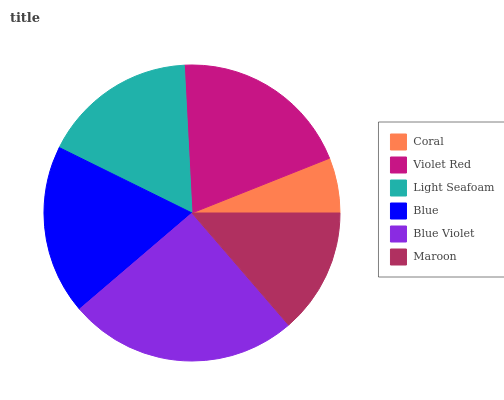Is Coral the minimum?
Answer yes or no. Yes. Is Blue Violet the maximum?
Answer yes or no. Yes. Is Violet Red the minimum?
Answer yes or no. No. Is Violet Red the maximum?
Answer yes or no. No. Is Violet Red greater than Coral?
Answer yes or no. Yes. Is Coral less than Violet Red?
Answer yes or no. Yes. Is Coral greater than Violet Red?
Answer yes or no. No. Is Violet Red less than Coral?
Answer yes or no. No. Is Blue the high median?
Answer yes or no. Yes. Is Light Seafoam the low median?
Answer yes or no. Yes. Is Violet Red the high median?
Answer yes or no. No. Is Violet Red the low median?
Answer yes or no. No. 